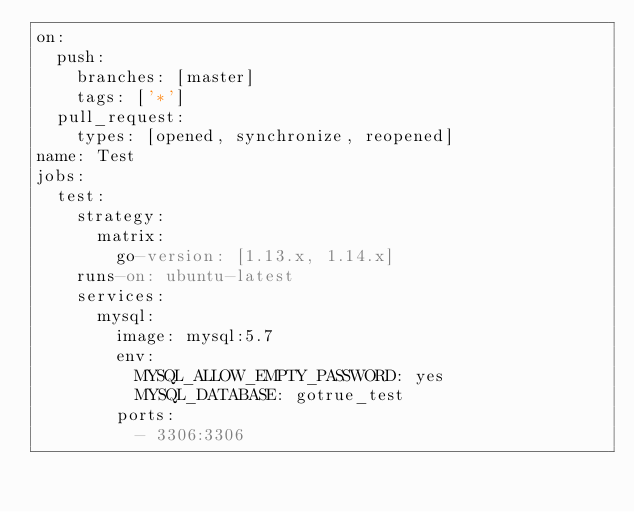<code> <loc_0><loc_0><loc_500><loc_500><_YAML_>on:
  push:
    branches: [master]
    tags: ['*']
  pull_request:
    types: [opened, synchronize, reopened]
name: Test
jobs:
  test:
    strategy:
      matrix:
        go-version: [1.13.x, 1.14.x]
    runs-on: ubuntu-latest
    services:
      mysql:
        image: mysql:5.7
        env:
          MYSQL_ALLOW_EMPTY_PASSWORD: yes
          MYSQL_DATABASE: gotrue_test
        ports:
          - 3306:3306</code> 